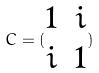Convert formula to latex. <formula><loc_0><loc_0><loc_500><loc_500>C = ( \begin{matrix} 1 & i \\ i & 1 \end{matrix} )</formula> 